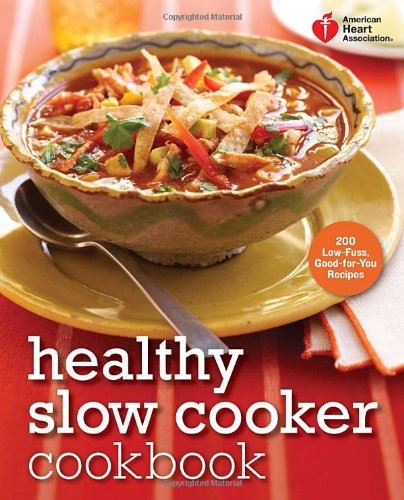Could this book be a good gift for someone who is newly acquainted with cooking? Definitely! This cookbook offers an excellent introduction to cooking for those new to the kitchen. It provides easy-to-follow recipes and tips to create healthy meals without overwhelming beginners. Its focus on simplicity and nutritional balance makes it an ideal gift. 